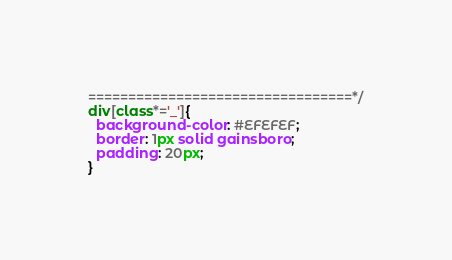<code> <loc_0><loc_0><loc_500><loc_500><_CSS_>=================================*/
div[class*='_']{
  background-color: #EFEFEF;
  border: 1px solid gainsboro;
  padding: 20px;
}
</code> 